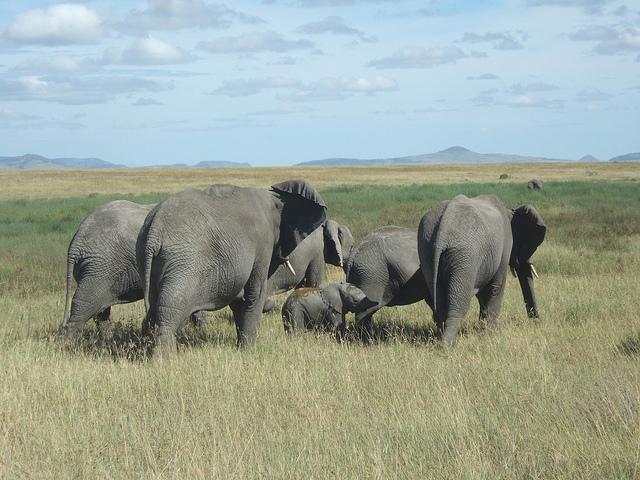Do the shadows and sky suggest this is around dusk?
Be succinct. No. Why is the baby in the middle?
Short answer required. Protection. Are all the elephants gray?
Concise answer only. Yes. Are these elephants dry?
Short answer required. Yes. How many elephants are there?
Keep it brief. 6. How many elephants are in the picture?
Be succinct. 6. What color are they?
Answer briefly. Gray. Is this out in the wild?
Keep it brief. Yes. Are the elephants fenced in?
Be succinct. No. Which elephant is the baby parents?
Give a very brief answer. One in front of it. Is the elephant dirty?
Quick response, please. No. 